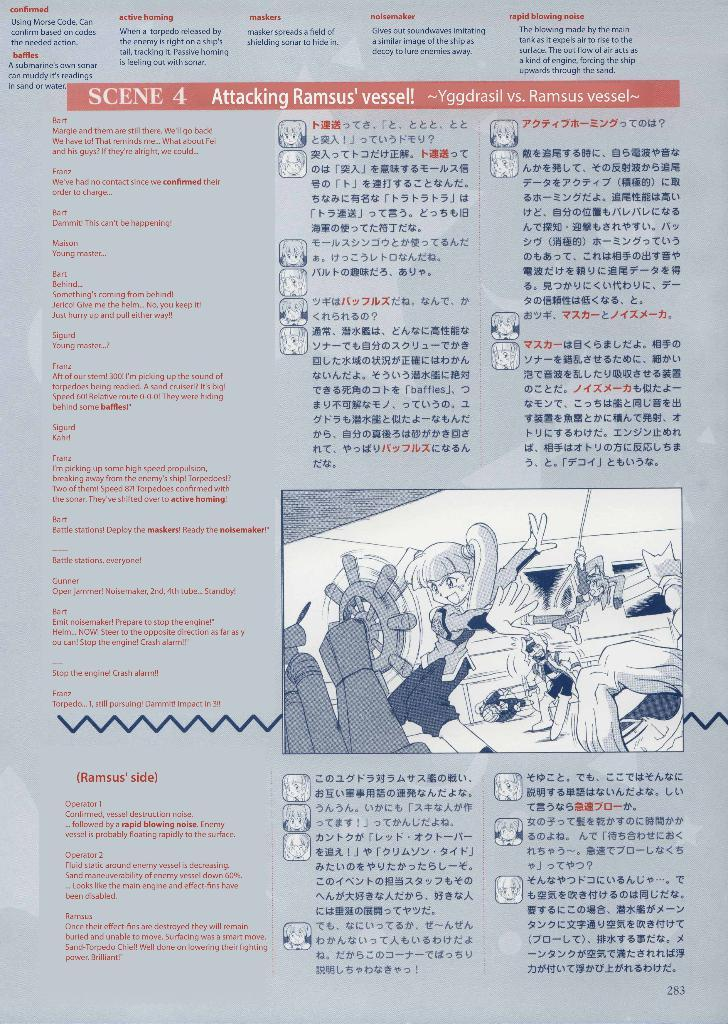<image>
Provide a brief description of the given image. A page of information about Scene 4, attacking Ramsus' vessel, includes an anime drawing of a girl spinning a ship's wheel. 